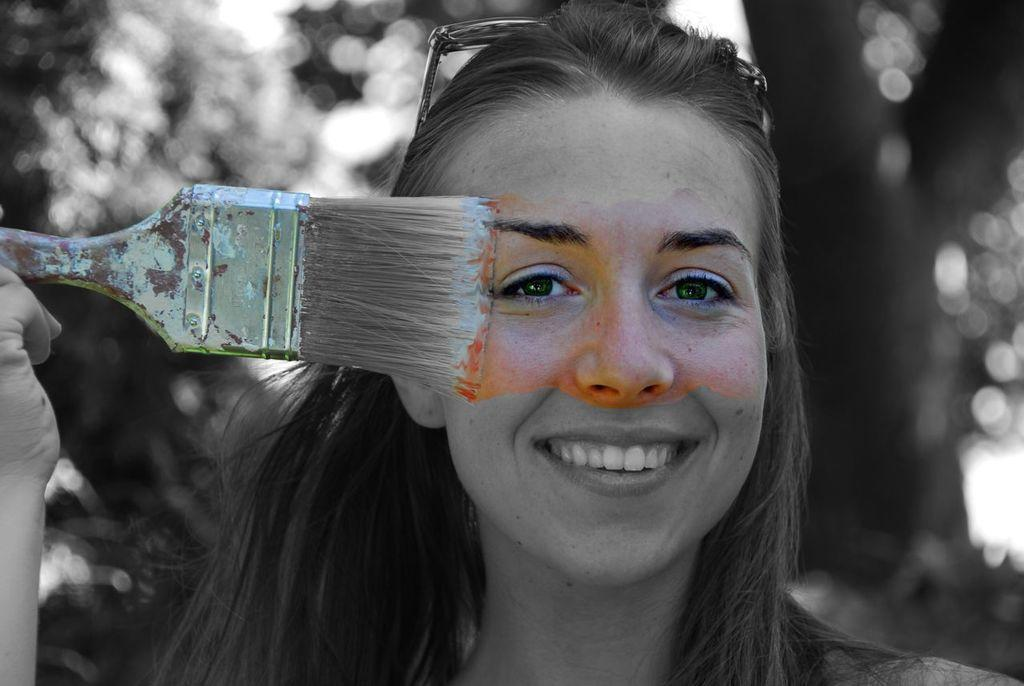Who is present in the image? There is a woman in the image. What is the woman holding in the image? The woman is holding a painting brush. What can be seen in the background of the image? There is a tree visible in the image. What type of argument is the woman having with the tree in the image? There is no argument present in the image; the woman is holding a painting brush, and a tree is visible in the background. 